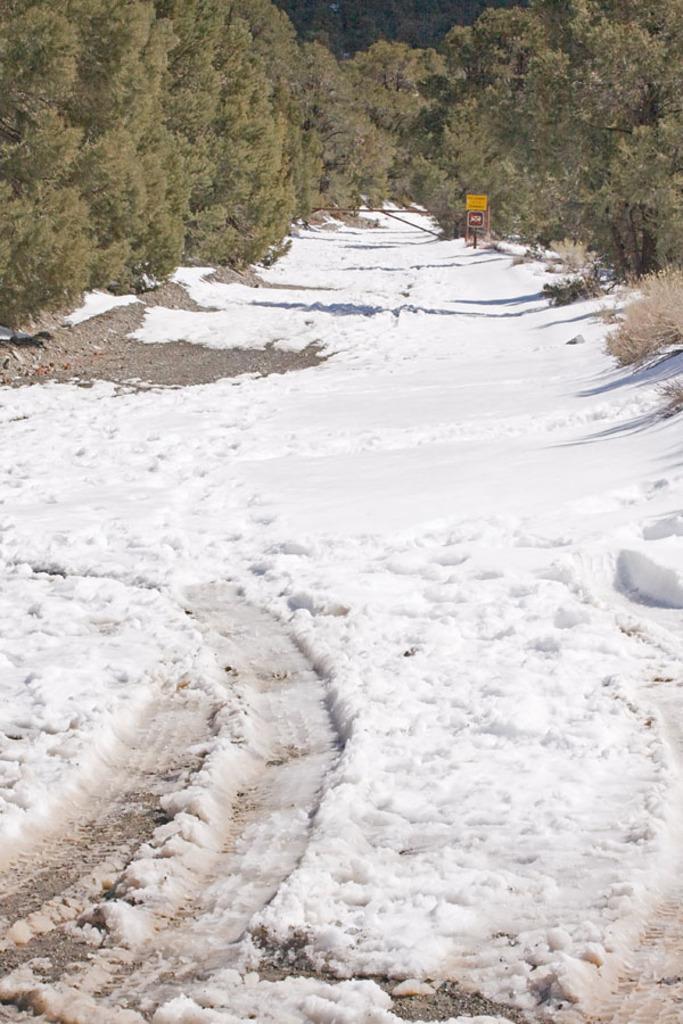Please provide a concise description of this image. In this image I can see snow. There is a board at the back. There are trees. 